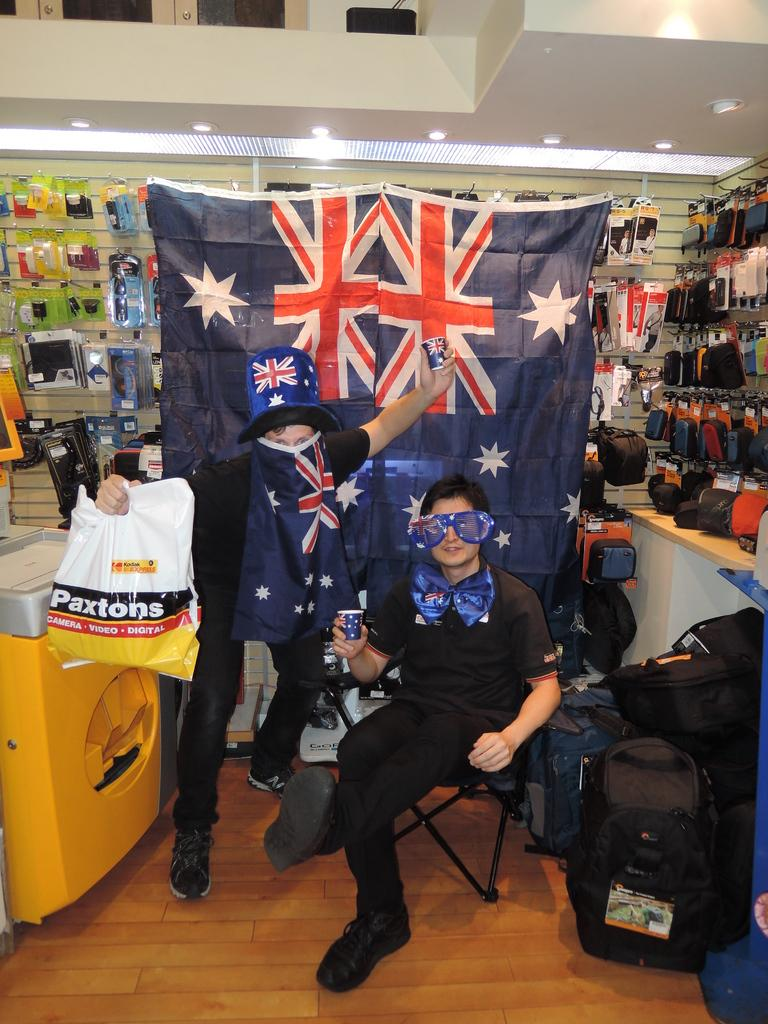<image>
Offer a succinct explanation of the picture presented. A child holds a bag that says "Paxtons" on the side. 